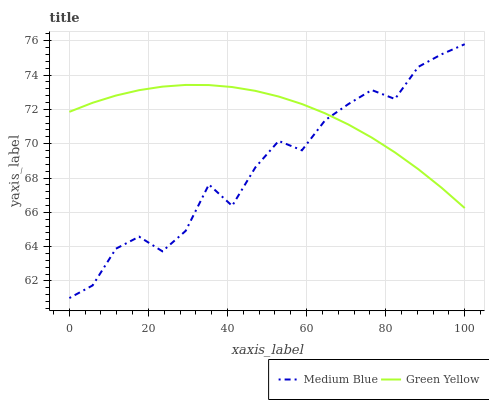Does Medium Blue have the minimum area under the curve?
Answer yes or no. Yes. Does Green Yellow have the maximum area under the curve?
Answer yes or no. Yes. Does Medium Blue have the maximum area under the curve?
Answer yes or no. No. Is Green Yellow the smoothest?
Answer yes or no. Yes. Is Medium Blue the roughest?
Answer yes or no. Yes. Is Medium Blue the smoothest?
Answer yes or no. No. Does Medium Blue have the lowest value?
Answer yes or no. Yes. Does Medium Blue have the highest value?
Answer yes or no. Yes. Does Medium Blue intersect Green Yellow?
Answer yes or no. Yes. Is Medium Blue less than Green Yellow?
Answer yes or no. No. Is Medium Blue greater than Green Yellow?
Answer yes or no. No. 